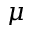Convert formula to latex. <formula><loc_0><loc_0><loc_500><loc_500>\mu</formula> 